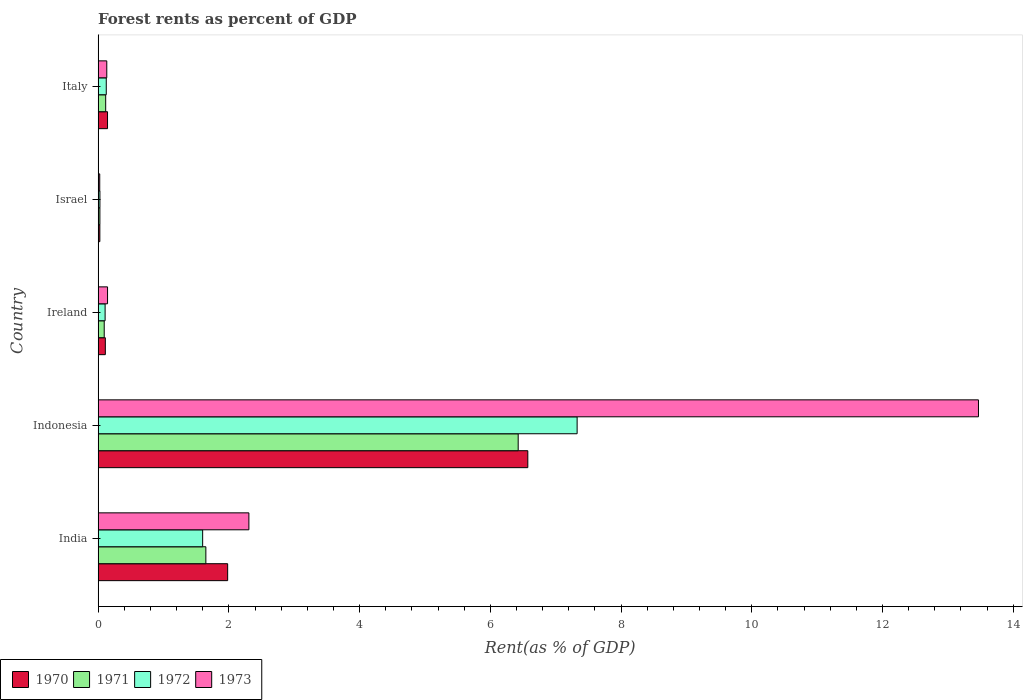Are the number of bars per tick equal to the number of legend labels?
Your answer should be compact. Yes. Are the number of bars on each tick of the Y-axis equal?
Offer a terse response. Yes. How many bars are there on the 2nd tick from the top?
Offer a very short reply. 4. In how many cases, is the number of bars for a given country not equal to the number of legend labels?
Keep it short and to the point. 0. What is the forest rent in 1970 in Indonesia?
Your response must be concise. 6.57. Across all countries, what is the maximum forest rent in 1970?
Provide a succinct answer. 6.57. Across all countries, what is the minimum forest rent in 1971?
Provide a succinct answer. 0.03. In which country was the forest rent in 1970 minimum?
Give a very brief answer. Israel. What is the total forest rent in 1971 in the graph?
Ensure brevity in your answer.  8.31. What is the difference between the forest rent in 1972 in India and that in Italy?
Offer a terse response. 1.47. What is the difference between the forest rent in 1971 in Ireland and the forest rent in 1972 in Indonesia?
Make the answer very short. -7.23. What is the average forest rent in 1972 per country?
Offer a very short reply. 1.84. What is the difference between the forest rent in 1972 and forest rent in 1973 in Israel?
Offer a very short reply. 0. In how many countries, is the forest rent in 1970 greater than 2.4 %?
Your answer should be very brief. 1. What is the ratio of the forest rent in 1972 in Indonesia to that in Israel?
Your answer should be compact. 265.68. Is the forest rent in 1972 in Indonesia less than that in Ireland?
Ensure brevity in your answer.  No. What is the difference between the highest and the second highest forest rent in 1973?
Ensure brevity in your answer.  11.16. What is the difference between the highest and the lowest forest rent in 1970?
Your response must be concise. 6.55. In how many countries, is the forest rent in 1972 greater than the average forest rent in 1972 taken over all countries?
Give a very brief answer. 1. Is it the case that in every country, the sum of the forest rent in 1973 and forest rent in 1971 is greater than the sum of forest rent in 1970 and forest rent in 1972?
Offer a terse response. No. What does the 1st bar from the top in India represents?
Offer a very short reply. 1973. What does the 3rd bar from the bottom in Israel represents?
Ensure brevity in your answer.  1972. Is it the case that in every country, the sum of the forest rent in 1971 and forest rent in 1972 is greater than the forest rent in 1973?
Your answer should be very brief. Yes. Are all the bars in the graph horizontal?
Your response must be concise. Yes. What is the difference between two consecutive major ticks on the X-axis?
Ensure brevity in your answer.  2. Are the values on the major ticks of X-axis written in scientific E-notation?
Provide a succinct answer. No. Does the graph contain grids?
Your answer should be very brief. No. Where does the legend appear in the graph?
Your response must be concise. Bottom left. What is the title of the graph?
Make the answer very short. Forest rents as percent of GDP. Does "1961" appear as one of the legend labels in the graph?
Keep it short and to the point. No. What is the label or title of the X-axis?
Your answer should be very brief. Rent(as % of GDP). What is the label or title of the Y-axis?
Offer a terse response. Country. What is the Rent(as % of GDP) in 1970 in India?
Offer a terse response. 1.98. What is the Rent(as % of GDP) of 1971 in India?
Ensure brevity in your answer.  1.65. What is the Rent(as % of GDP) in 1972 in India?
Provide a succinct answer. 1.6. What is the Rent(as % of GDP) in 1973 in India?
Offer a very short reply. 2.31. What is the Rent(as % of GDP) of 1970 in Indonesia?
Ensure brevity in your answer.  6.57. What is the Rent(as % of GDP) of 1971 in Indonesia?
Offer a very short reply. 6.43. What is the Rent(as % of GDP) of 1972 in Indonesia?
Provide a succinct answer. 7.33. What is the Rent(as % of GDP) of 1973 in Indonesia?
Your response must be concise. 13.47. What is the Rent(as % of GDP) of 1970 in Ireland?
Make the answer very short. 0.11. What is the Rent(as % of GDP) in 1971 in Ireland?
Your response must be concise. 0.09. What is the Rent(as % of GDP) of 1972 in Ireland?
Your answer should be compact. 0.11. What is the Rent(as % of GDP) in 1973 in Ireland?
Ensure brevity in your answer.  0.14. What is the Rent(as % of GDP) of 1970 in Israel?
Ensure brevity in your answer.  0.03. What is the Rent(as % of GDP) of 1971 in Israel?
Ensure brevity in your answer.  0.03. What is the Rent(as % of GDP) in 1972 in Israel?
Your answer should be compact. 0.03. What is the Rent(as % of GDP) of 1973 in Israel?
Your response must be concise. 0.02. What is the Rent(as % of GDP) of 1970 in Italy?
Your response must be concise. 0.14. What is the Rent(as % of GDP) in 1971 in Italy?
Provide a succinct answer. 0.12. What is the Rent(as % of GDP) of 1972 in Italy?
Keep it short and to the point. 0.12. What is the Rent(as % of GDP) in 1973 in Italy?
Provide a short and direct response. 0.13. Across all countries, what is the maximum Rent(as % of GDP) of 1970?
Offer a terse response. 6.57. Across all countries, what is the maximum Rent(as % of GDP) of 1971?
Your response must be concise. 6.43. Across all countries, what is the maximum Rent(as % of GDP) of 1972?
Provide a succinct answer. 7.33. Across all countries, what is the maximum Rent(as % of GDP) in 1973?
Your answer should be very brief. 13.47. Across all countries, what is the minimum Rent(as % of GDP) of 1970?
Provide a succinct answer. 0.03. Across all countries, what is the minimum Rent(as % of GDP) of 1971?
Your answer should be compact. 0.03. Across all countries, what is the minimum Rent(as % of GDP) in 1972?
Provide a short and direct response. 0.03. Across all countries, what is the minimum Rent(as % of GDP) in 1973?
Provide a short and direct response. 0.02. What is the total Rent(as % of GDP) in 1970 in the graph?
Keep it short and to the point. 8.84. What is the total Rent(as % of GDP) of 1971 in the graph?
Your response must be concise. 8.31. What is the total Rent(as % of GDP) of 1972 in the graph?
Offer a very short reply. 9.19. What is the total Rent(as % of GDP) of 1973 in the graph?
Offer a terse response. 16.08. What is the difference between the Rent(as % of GDP) in 1970 in India and that in Indonesia?
Keep it short and to the point. -4.59. What is the difference between the Rent(as % of GDP) in 1971 in India and that in Indonesia?
Your response must be concise. -4.78. What is the difference between the Rent(as % of GDP) of 1972 in India and that in Indonesia?
Offer a very short reply. -5.73. What is the difference between the Rent(as % of GDP) in 1973 in India and that in Indonesia?
Ensure brevity in your answer.  -11.16. What is the difference between the Rent(as % of GDP) in 1970 in India and that in Ireland?
Your answer should be very brief. 1.87. What is the difference between the Rent(as % of GDP) of 1971 in India and that in Ireland?
Provide a short and direct response. 1.55. What is the difference between the Rent(as % of GDP) in 1972 in India and that in Ireland?
Make the answer very short. 1.49. What is the difference between the Rent(as % of GDP) of 1973 in India and that in Ireland?
Give a very brief answer. 2.16. What is the difference between the Rent(as % of GDP) in 1970 in India and that in Israel?
Your response must be concise. 1.96. What is the difference between the Rent(as % of GDP) in 1971 in India and that in Israel?
Give a very brief answer. 1.62. What is the difference between the Rent(as % of GDP) of 1972 in India and that in Israel?
Offer a very short reply. 1.57. What is the difference between the Rent(as % of GDP) of 1973 in India and that in Israel?
Provide a succinct answer. 2.28. What is the difference between the Rent(as % of GDP) of 1970 in India and that in Italy?
Your response must be concise. 1.84. What is the difference between the Rent(as % of GDP) of 1971 in India and that in Italy?
Your answer should be compact. 1.53. What is the difference between the Rent(as % of GDP) of 1972 in India and that in Italy?
Offer a terse response. 1.47. What is the difference between the Rent(as % of GDP) in 1973 in India and that in Italy?
Give a very brief answer. 2.17. What is the difference between the Rent(as % of GDP) in 1970 in Indonesia and that in Ireland?
Keep it short and to the point. 6.46. What is the difference between the Rent(as % of GDP) in 1971 in Indonesia and that in Ireland?
Your answer should be very brief. 6.33. What is the difference between the Rent(as % of GDP) in 1972 in Indonesia and that in Ireland?
Your response must be concise. 7.22. What is the difference between the Rent(as % of GDP) in 1973 in Indonesia and that in Ireland?
Your response must be concise. 13.32. What is the difference between the Rent(as % of GDP) in 1970 in Indonesia and that in Israel?
Your response must be concise. 6.55. What is the difference between the Rent(as % of GDP) in 1971 in Indonesia and that in Israel?
Offer a terse response. 6.4. What is the difference between the Rent(as % of GDP) of 1972 in Indonesia and that in Israel?
Your answer should be very brief. 7.3. What is the difference between the Rent(as % of GDP) in 1973 in Indonesia and that in Israel?
Your response must be concise. 13.44. What is the difference between the Rent(as % of GDP) in 1970 in Indonesia and that in Italy?
Offer a terse response. 6.43. What is the difference between the Rent(as % of GDP) in 1971 in Indonesia and that in Italy?
Provide a short and direct response. 6.31. What is the difference between the Rent(as % of GDP) of 1972 in Indonesia and that in Italy?
Your answer should be compact. 7.2. What is the difference between the Rent(as % of GDP) in 1973 in Indonesia and that in Italy?
Make the answer very short. 13.34. What is the difference between the Rent(as % of GDP) in 1970 in Ireland and that in Israel?
Make the answer very short. 0.08. What is the difference between the Rent(as % of GDP) of 1971 in Ireland and that in Israel?
Ensure brevity in your answer.  0.07. What is the difference between the Rent(as % of GDP) of 1972 in Ireland and that in Israel?
Your answer should be very brief. 0.08. What is the difference between the Rent(as % of GDP) of 1973 in Ireland and that in Israel?
Offer a terse response. 0.12. What is the difference between the Rent(as % of GDP) of 1970 in Ireland and that in Italy?
Ensure brevity in your answer.  -0.03. What is the difference between the Rent(as % of GDP) of 1971 in Ireland and that in Italy?
Your answer should be compact. -0.02. What is the difference between the Rent(as % of GDP) of 1972 in Ireland and that in Italy?
Provide a succinct answer. -0.02. What is the difference between the Rent(as % of GDP) in 1973 in Ireland and that in Italy?
Offer a very short reply. 0.01. What is the difference between the Rent(as % of GDP) in 1970 in Israel and that in Italy?
Your answer should be compact. -0.12. What is the difference between the Rent(as % of GDP) of 1971 in Israel and that in Italy?
Make the answer very short. -0.09. What is the difference between the Rent(as % of GDP) in 1972 in Israel and that in Italy?
Your answer should be compact. -0.1. What is the difference between the Rent(as % of GDP) in 1973 in Israel and that in Italy?
Ensure brevity in your answer.  -0.11. What is the difference between the Rent(as % of GDP) in 1970 in India and the Rent(as % of GDP) in 1971 in Indonesia?
Offer a terse response. -4.44. What is the difference between the Rent(as % of GDP) of 1970 in India and the Rent(as % of GDP) of 1972 in Indonesia?
Your answer should be compact. -5.35. What is the difference between the Rent(as % of GDP) of 1970 in India and the Rent(as % of GDP) of 1973 in Indonesia?
Your answer should be very brief. -11.49. What is the difference between the Rent(as % of GDP) of 1971 in India and the Rent(as % of GDP) of 1972 in Indonesia?
Keep it short and to the point. -5.68. What is the difference between the Rent(as % of GDP) of 1971 in India and the Rent(as % of GDP) of 1973 in Indonesia?
Keep it short and to the point. -11.82. What is the difference between the Rent(as % of GDP) of 1972 in India and the Rent(as % of GDP) of 1973 in Indonesia?
Make the answer very short. -11.87. What is the difference between the Rent(as % of GDP) in 1970 in India and the Rent(as % of GDP) in 1971 in Ireland?
Ensure brevity in your answer.  1.89. What is the difference between the Rent(as % of GDP) of 1970 in India and the Rent(as % of GDP) of 1972 in Ireland?
Offer a terse response. 1.87. What is the difference between the Rent(as % of GDP) of 1970 in India and the Rent(as % of GDP) of 1973 in Ireland?
Offer a very short reply. 1.84. What is the difference between the Rent(as % of GDP) of 1971 in India and the Rent(as % of GDP) of 1972 in Ireland?
Provide a short and direct response. 1.54. What is the difference between the Rent(as % of GDP) in 1971 in India and the Rent(as % of GDP) in 1973 in Ireland?
Make the answer very short. 1.5. What is the difference between the Rent(as % of GDP) in 1972 in India and the Rent(as % of GDP) in 1973 in Ireland?
Give a very brief answer. 1.46. What is the difference between the Rent(as % of GDP) in 1970 in India and the Rent(as % of GDP) in 1971 in Israel?
Your answer should be very brief. 1.95. What is the difference between the Rent(as % of GDP) of 1970 in India and the Rent(as % of GDP) of 1972 in Israel?
Ensure brevity in your answer.  1.95. What is the difference between the Rent(as % of GDP) in 1970 in India and the Rent(as % of GDP) in 1973 in Israel?
Provide a short and direct response. 1.96. What is the difference between the Rent(as % of GDP) in 1971 in India and the Rent(as % of GDP) in 1972 in Israel?
Your response must be concise. 1.62. What is the difference between the Rent(as % of GDP) in 1971 in India and the Rent(as % of GDP) in 1973 in Israel?
Provide a succinct answer. 1.62. What is the difference between the Rent(as % of GDP) of 1972 in India and the Rent(as % of GDP) of 1973 in Israel?
Give a very brief answer. 1.57. What is the difference between the Rent(as % of GDP) of 1970 in India and the Rent(as % of GDP) of 1971 in Italy?
Provide a short and direct response. 1.87. What is the difference between the Rent(as % of GDP) in 1970 in India and the Rent(as % of GDP) in 1972 in Italy?
Offer a very short reply. 1.86. What is the difference between the Rent(as % of GDP) of 1970 in India and the Rent(as % of GDP) of 1973 in Italy?
Make the answer very short. 1.85. What is the difference between the Rent(as % of GDP) in 1971 in India and the Rent(as % of GDP) in 1972 in Italy?
Your answer should be very brief. 1.52. What is the difference between the Rent(as % of GDP) of 1971 in India and the Rent(as % of GDP) of 1973 in Italy?
Make the answer very short. 1.52. What is the difference between the Rent(as % of GDP) in 1972 in India and the Rent(as % of GDP) in 1973 in Italy?
Give a very brief answer. 1.47. What is the difference between the Rent(as % of GDP) of 1970 in Indonesia and the Rent(as % of GDP) of 1971 in Ireland?
Make the answer very short. 6.48. What is the difference between the Rent(as % of GDP) in 1970 in Indonesia and the Rent(as % of GDP) in 1972 in Ireland?
Your response must be concise. 6.47. What is the difference between the Rent(as % of GDP) in 1970 in Indonesia and the Rent(as % of GDP) in 1973 in Ireland?
Your response must be concise. 6.43. What is the difference between the Rent(as % of GDP) in 1971 in Indonesia and the Rent(as % of GDP) in 1972 in Ireland?
Your answer should be compact. 6.32. What is the difference between the Rent(as % of GDP) in 1971 in Indonesia and the Rent(as % of GDP) in 1973 in Ireland?
Ensure brevity in your answer.  6.28. What is the difference between the Rent(as % of GDP) in 1972 in Indonesia and the Rent(as % of GDP) in 1973 in Ireland?
Provide a succinct answer. 7.18. What is the difference between the Rent(as % of GDP) in 1970 in Indonesia and the Rent(as % of GDP) in 1971 in Israel?
Offer a terse response. 6.55. What is the difference between the Rent(as % of GDP) of 1970 in Indonesia and the Rent(as % of GDP) of 1972 in Israel?
Ensure brevity in your answer.  6.55. What is the difference between the Rent(as % of GDP) in 1970 in Indonesia and the Rent(as % of GDP) in 1973 in Israel?
Offer a terse response. 6.55. What is the difference between the Rent(as % of GDP) in 1971 in Indonesia and the Rent(as % of GDP) in 1972 in Israel?
Give a very brief answer. 6.4. What is the difference between the Rent(as % of GDP) of 1971 in Indonesia and the Rent(as % of GDP) of 1973 in Israel?
Give a very brief answer. 6.4. What is the difference between the Rent(as % of GDP) of 1972 in Indonesia and the Rent(as % of GDP) of 1973 in Israel?
Make the answer very short. 7.3. What is the difference between the Rent(as % of GDP) in 1970 in Indonesia and the Rent(as % of GDP) in 1971 in Italy?
Provide a short and direct response. 6.46. What is the difference between the Rent(as % of GDP) in 1970 in Indonesia and the Rent(as % of GDP) in 1972 in Italy?
Give a very brief answer. 6.45. What is the difference between the Rent(as % of GDP) in 1970 in Indonesia and the Rent(as % of GDP) in 1973 in Italy?
Provide a short and direct response. 6.44. What is the difference between the Rent(as % of GDP) in 1971 in Indonesia and the Rent(as % of GDP) in 1972 in Italy?
Keep it short and to the point. 6.3. What is the difference between the Rent(as % of GDP) in 1971 in Indonesia and the Rent(as % of GDP) in 1973 in Italy?
Your answer should be compact. 6.29. What is the difference between the Rent(as % of GDP) in 1972 in Indonesia and the Rent(as % of GDP) in 1973 in Italy?
Provide a short and direct response. 7.2. What is the difference between the Rent(as % of GDP) of 1970 in Ireland and the Rent(as % of GDP) of 1971 in Israel?
Offer a very short reply. 0.08. What is the difference between the Rent(as % of GDP) in 1970 in Ireland and the Rent(as % of GDP) in 1972 in Israel?
Keep it short and to the point. 0.08. What is the difference between the Rent(as % of GDP) of 1970 in Ireland and the Rent(as % of GDP) of 1973 in Israel?
Keep it short and to the point. 0.09. What is the difference between the Rent(as % of GDP) in 1971 in Ireland and the Rent(as % of GDP) in 1972 in Israel?
Give a very brief answer. 0.07. What is the difference between the Rent(as % of GDP) of 1971 in Ireland and the Rent(as % of GDP) of 1973 in Israel?
Provide a short and direct response. 0.07. What is the difference between the Rent(as % of GDP) in 1972 in Ireland and the Rent(as % of GDP) in 1973 in Israel?
Ensure brevity in your answer.  0.08. What is the difference between the Rent(as % of GDP) of 1970 in Ireland and the Rent(as % of GDP) of 1971 in Italy?
Ensure brevity in your answer.  -0.01. What is the difference between the Rent(as % of GDP) of 1970 in Ireland and the Rent(as % of GDP) of 1972 in Italy?
Make the answer very short. -0.01. What is the difference between the Rent(as % of GDP) of 1970 in Ireland and the Rent(as % of GDP) of 1973 in Italy?
Offer a very short reply. -0.02. What is the difference between the Rent(as % of GDP) in 1971 in Ireland and the Rent(as % of GDP) in 1972 in Italy?
Keep it short and to the point. -0.03. What is the difference between the Rent(as % of GDP) of 1971 in Ireland and the Rent(as % of GDP) of 1973 in Italy?
Keep it short and to the point. -0.04. What is the difference between the Rent(as % of GDP) of 1972 in Ireland and the Rent(as % of GDP) of 1973 in Italy?
Your answer should be very brief. -0.03. What is the difference between the Rent(as % of GDP) in 1970 in Israel and the Rent(as % of GDP) in 1971 in Italy?
Your response must be concise. -0.09. What is the difference between the Rent(as % of GDP) of 1970 in Israel and the Rent(as % of GDP) of 1972 in Italy?
Provide a succinct answer. -0.1. What is the difference between the Rent(as % of GDP) in 1970 in Israel and the Rent(as % of GDP) in 1973 in Italy?
Offer a terse response. -0.11. What is the difference between the Rent(as % of GDP) of 1971 in Israel and the Rent(as % of GDP) of 1972 in Italy?
Your answer should be very brief. -0.1. What is the difference between the Rent(as % of GDP) in 1971 in Israel and the Rent(as % of GDP) in 1973 in Italy?
Make the answer very short. -0.11. What is the difference between the Rent(as % of GDP) in 1972 in Israel and the Rent(as % of GDP) in 1973 in Italy?
Ensure brevity in your answer.  -0.1. What is the average Rent(as % of GDP) in 1970 per country?
Provide a short and direct response. 1.77. What is the average Rent(as % of GDP) of 1971 per country?
Provide a short and direct response. 1.66. What is the average Rent(as % of GDP) in 1972 per country?
Provide a succinct answer. 1.84. What is the average Rent(as % of GDP) in 1973 per country?
Make the answer very short. 3.22. What is the difference between the Rent(as % of GDP) of 1970 and Rent(as % of GDP) of 1971 in India?
Ensure brevity in your answer.  0.33. What is the difference between the Rent(as % of GDP) of 1970 and Rent(as % of GDP) of 1972 in India?
Your answer should be very brief. 0.38. What is the difference between the Rent(as % of GDP) in 1970 and Rent(as % of GDP) in 1973 in India?
Offer a very short reply. -0.32. What is the difference between the Rent(as % of GDP) of 1971 and Rent(as % of GDP) of 1972 in India?
Keep it short and to the point. 0.05. What is the difference between the Rent(as % of GDP) in 1971 and Rent(as % of GDP) in 1973 in India?
Your response must be concise. -0.66. What is the difference between the Rent(as % of GDP) of 1972 and Rent(as % of GDP) of 1973 in India?
Keep it short and to the point. -0.71. What is the difference between the Rent(as % of GDP) of 1970 and Rent(as % of GDP) of 1971 in Indonesia?
Your answer should be compact. 0.15. What is the difference between the Rent(as % of GDP) of 1970 and Rent(as % of GDP) of 1972 in Indonesia?
Offer a terse response. -0.75. What is the difference between the Rent(as % of GDP) in 1970 and Rent(as % of GDP) in 1973 in Indonesia?
Your response must be concise. -6.89. What is the difference between the Rent(as % of GDP) in 1971 and Rent(as % of GDP) in 1972 in Indonesia?
Offer a very short reply. -0.9. What is the difference between the Rent(as % of GDP) of 1971 and Rent(as % of GDP) of 1973 in Indonesia?
Your answer should be very brief. -7.04. What is the difference between the Rent(as % of GDP) in 1972 and Rent(as % of GDP) in 1973 in Indonesia?
Ensure brevity in your answer.  -6.14. What is the difference between the Rent(as % of GDP) of 1970 and Rent(as % of GDP) of 1971 in Ireland?
Your answer should be compact. 0.02. What is the difference between the Rent(as % of GDP) in 1970 and Rent(as % of GDP) in 1972 in Ireland?
Make the answer very short. 0. What is the difference between the Rent(as % of GDP) of 1970 and Rent(as % of GDP) of 1973 in Ireland?
Ensure brevity in your answer.  -0.03. What is the difference between the Rent(as % of GDP) in 1971 and Rent(as % of GDP) in 1972 in Ireland?
Keep it short and to the point. -0.01. What is the difference between the Rent(as % of GDP) in 1971 and Rent(as % of GDP) in 1973 in Ireland?
Keep it short and to the point. -0.05. What is the difference between the Rent(as % of GDP) in 1972 and Rent(as % of GDP) in 1973 in Ireland?
Keep it short and to the point. -0.04. What is the difference between the Rent(as % of GDP) in 1970 and Rent(as % of GDP) in 1971 in Israel?
Keep it short and to the point. -0. What is the difference between the Rent(as % of GDP) in 1970 and Rent(as % of GDP) in 1972 in Israel?
Your answer should be compact. -0. What is the difference between the Rent(as % of GDP) in 1970 and Rent(as % of GDP) in 1973 in Israel?
Your response must be concise. 0. What is the difference between the Rent(as % of GDP) of 1971 and Rent(as % of GDP) of 1972 in Israel?
Offer a very short reply. -0. What is the difference between the Rent(as % of GDP) of 1971 and Rent(as % of GDP) of 1973 in Israel?
Provide a short and direct response. 0. What is the difference between the Rent(as % of GDP) in 1972 and Rent(as % of GDP) in 1973 in Israel?
Your answer should be very brief. 0. What is the difference between the Rent(as % of GDP) of 1970 and Rent(as % of GDP) of 1971 in Italy?
Your response must be concise. 0.03. What is the difference between the Rent(as % of GDP) of 1970 and Rent(as % of GDP) of 1972 in Italy?
Offer a terse response. 0.02. What is the difference between the Rent(as % of GDP) of 1970 and Rent(as % of GDP) of 1973 in Italy?
Provide a succinct answer. 0.01. What is the difference between the Rent(as % of GDP) in 1971 and Rent(as % of GDP) in 1972 in Italy?
Provide a short and direct response. -0.01. What is the difference between the Rent(as % of GDP) of 1971 and Rent(as % of GDP) of 1973 in Italy?
Offer a terse response. -0.02. What is the difference between the Rent(as % of GDP) of 1972 and Rent(as % of GDP) of 1973 in Italy?
Keep it short and to the point. -0.01. What is the ratio of the Rent(as % of GDP) in 1970 in India to that in Indonesia?
Your answer should be compact. 0.3. What is the ratio of the Rent(as % of GDP) of 1971 in India to that in Indonesia?
Provide a short and direct response. 0.26. What is the ratio of the Rent(as % of GDP) in 1972 in India to that in Indonesia?
Your answer should be compact. 0.22. What is the ratio of the Rent(as % of GDP) of 1973 in India to that in Indonesia?
Give a very brief answer. 0.17. What is the ratio of the Rent(as % of GDP) of 1970 in India to that in Ireland?
Offer a terse response. 17.97. What is the ratio of the Rent(as % of GDP) of 1971 in India to that in Ireland?
Your answer should be very brief. 17.67. What is the ratio of the Rent(as % of GDP) in 1972 in India to that in Ireland?
Offer a very short reply. 14.95. What is the ratio of the Rent(as % of GDP) of 1973 in India to that in Ireland?
Your response must be concise. 16. What is the ratio of the Rent(as % of GDP) in 1970 in India to that in Israel?
Your answer should be compact. 74.79. What is the ratio of the Rent(as % of GDP) in 1971 in India to that in Israel?
Offer a terse response. 60.95. What is the ratio of the Rent(as % of GDP) in 1972 in India to that in Israel?
Offer a terse response. 57.98. What is the ratio of the Rent(as % of GDP) in 1973 in India to that in Israel?
Keep it short and to the point. 93.32. What is the ratio of the Rent(as % of GDP) of 1970 in India to that in Italy?
Make the answer very short. 13.76. What is the ratio of the Rent(as % of GDP) of 1971 in India to that in Italy?
Give a very brief answer. 14.23. What is the ratio of the Rent(as % of GDP) of 1972 in India to that in Italy?
Offer a very short reply. 12.84. What is the ratio of the Rent(as % of GDP) in 1973 in India to that in Italy?
Give a very brief answer. 17.4. What is the ratio of the Rent(as % of GDP) in 1970 in Indonesia to that in Ireland?
Your answer should be very brief. 59.6. What is the ratio of the Rent(as % of GDP) in 1971 in Indonesia to that in Ireland?
Make the answer very short. 68.89. What is the ratio of the Rent(as % of GDP) in 1972 in Indonesia to that in Ireland?
Your response must be concise. 68.52. What is the ratio of the Rent(as % of GDP) in 1973 in Indonesia to that in Ireland?
Your answer should be very brief. 93.39. What is the ratio of the Rent(as % of GDP) in 1970 in Indonesia to that in Israel?
Provide a short and direct response. 248.09. What is the ratio of the Rent(as % of GDP) in 1971 in Indonesia to that in Israel?
Ensure brevity in your answer.  237.62. What is the ratio of the Rent(as % of GDP) of 1972 in Indonesia to that in Israel?
Your response must be concise. 265.68. What is the ratio of the Rent(as % of GDP) of 1973 in Indonesia to that in Israel?
Keep it short and to the point. 544.86. What is the ratio of the Rent(as % of GDP) of 1970 in Indonesia to that in Italy?
Your answer should be compact. 45.64. What is the ratio of the Rent(as % of GDP) of 1971 in Indonesia to that in Italy?
Your answer should be very brief. 55.49. What is the ratio of the Rent(as % of GDP) of 1972 in Indonesia to that in Italy?
Make the answer very short. 58.84. What is the ratio of the Rent(as % of GDP) in 1973 in Indonesia to that in Italy?
Give a very brief answer. 101.6. What is the ratio of the Rent(as % of GDP) in 1970 in Ireland to that in Israel?
Your answer should be compact. 4.16. What is the ratio of the Rent(as % of GDP) in 1971 in Ireland to that in Israel?
Ensure brevity in your answer.  3.45. What is the ratio of the Rent(as % of GDP) in 1972 in Ireland to that in Israel?
Offer a very short reply. 3.88. What is the ratio of the Rent(as % of GDP) of 1973 in Ireland to that in Israel?
Ensure brevity in your answer.  5.83. What is the ratio of the Rent(as % of GDP) of 1970 in Ireland to that in Italy?
Your response must be concise. 0.77. What is the ratio of the Rent(as % of GDP) of 1971 in Ireland to that in Italy?
Keep it short and to the point. 0.81. What is the ratio of the Rent(as % of GDP) in 1972 in Ireland to that in Italy?
Keep it short and to the point. 0.86. What is the ratio of the Rent(as % of GDP) of 1973 in Ireland to that in Italy?
Your response must be concise. 1.09. What is the ratio of the Rent(as % of GDP) in 1970 in Israel to that in Italy?
Offer a very short reply. 0.18. What is the ratio of the Rent(as % of GDP) in 1971 in Israel to that in Italy?
Your response must be concise. 0.23. What is the ratio of the Rent(as % of GDP) in 1972 in Israel to that in Italy?
Make the answer very short. 0.22. What is the ratio of the Rent(as % of GDP) in 1973 in Israel to that in Italy?
Give a very brief answer. 0.19. What is the difference between the highest and the second highest Rent(as % of GDP) in 1970?
Offer a very short reply. 4.59. What is the difference between the highest and the second highest Rent(as % of GDP) in 1971?
Your answer should be very brief. 4.78. What is the difference between the highest and the second highest Rent(as % of GDP) of 1972?
Make the answer very short. 5.73. What is the difference between the highest and the second highest Rent(as % of GDP) in 1973?
Ensure brevity in your answer.  11.16. What is the difference between the highest and the lowest Rent(as % of GDP) of 1970?
Your response must be concise. 6.55. What is the difference between the highest and the lowest Rent(as % of GDP) of 1971?
Your answer should be compact. 6.4. What is the difference between the highest and the lowest Rent(as % of GDP) in 1972?
Your response must be concise. 7.3. What is the difference between the highest and the lowest Rent(as % of GDP) in 1973?
Provide a succinct answer. 13.44. 